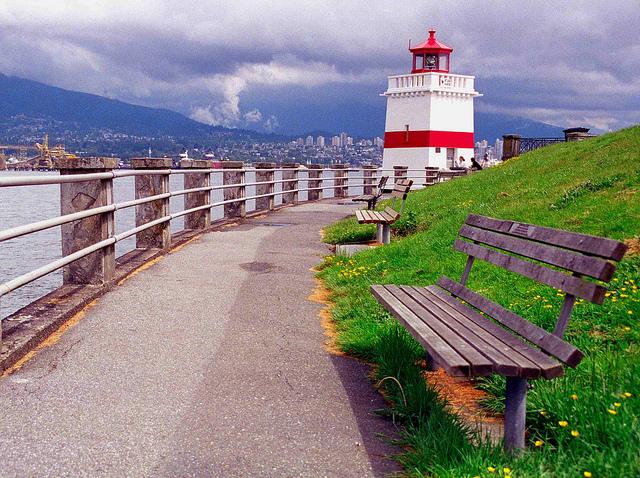Is it raining?
Concise answer only. No. What color are the little flowers?
Quick response, please. Yellow. What color is the grass?
Short answer required. Green. 